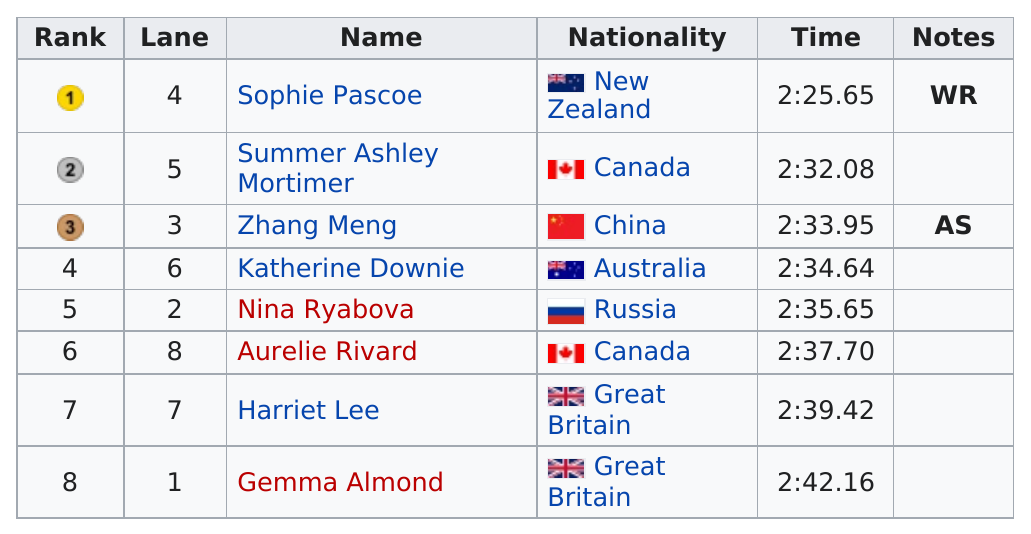Specify some key components in this picture. Six participants have a time between 2:30 and 2:40. At the 2012 Summer Paralympics, Zhang Meng was the only participant from China in the women's 200 meter individual medley SM10 event. At the women's 200 meter individual medley SM10 event at the 2012 Summer Paralympics, Sophie Pascoe finished in first place. Sophie Pascoe is the only swimmer with a time of less than 2:30. Lee was one of two swimmers from Great Britain. The second swimmer was Gemma Almond. 